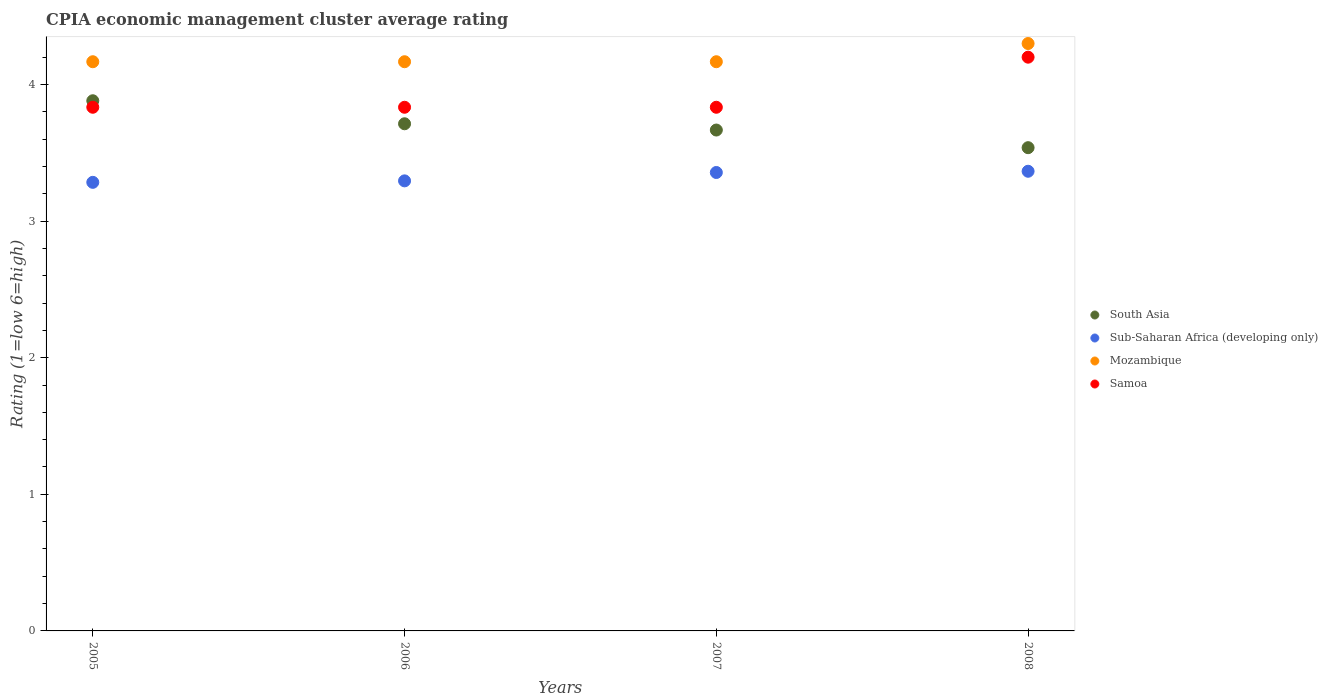How many different coloured dotlines are there?
Make the answer very short. 4. Across all years, what is the maximum CPIA rating in Mozambique?
Provide a short and direct response. 4.3. Across all years, what is the minimum CPIA rating in Sub-Saharan Africa (developing only)?
Provide a short and direct response. 3.28. What is the total CPIA rating in Mozambique in the graph?
Offer a very short reply. 16.8. What is the difference between the CPIA rating in Sub-Saharan Africa (developing only) in 2006 and that in 2007?
Ensure brevity in your answer.  -0.06. What is the difference between the CPIA rating in Sub-Saharan Africa (developing only) in 2005 and the CPIA rating in Mozambique in 2008?
Provide a succinct answer. -1.02. What is the average CPIA rating in Samoa per year?
Ensure brevity in your answer.  3.92. In the year 2006, what is the difference between the CPIA rating in Mozambique and CPIA rating in Sub-Saharan Africa (developing only)?
Your answer should be compact. 0.87. What is the ratio of the CPIA rating in Samoa in 2005 to that in 2008?
Provide a succinct answer. 0.91. What is the difference between the highest and the second highest CPIA rating in Samoa?
Ensure brevity in your answer.  0.37. What is the difference between the highest and the lowest CPIA rating in Sub-Saharan Africa (developing only)?
Offer a terse response. 0.08. Is it the case that in every year, the sum of the CPIA rating in Mozambique and CPIA rating in South Asia  is greater than the sum of CPIA rating in Sub-Saharan Africa (developing only) and CPIA rating in Samoa?
Offer a very short reply. Yes. What is the difference between two consecutive major ticks on the Y-axis?
Give a very brief answer. 1. Does the graph contain grids?
Your answer should be very brief. No. Where does the legend appear in the graph?
Provide a short and direct response. Center right. How many legend labels are there?
Provide a short and direct response. 4. What is the title of the graph?
Provide a succinct answer. CPIA economic management cluster average rating. Does "Tunisia" appear as one of the legend labels in the graph?
Give a very brief answer. No. What is the Rating (1=low 6=high) of South Asia in 2005?
Keep it short and to the point. 3.88. What is the Rating (1=low 6=high) of Sub-Saharan Africa (developing only) in 2005?
Your response must be concise. 3.28. What is the Rating (1=low 6=high) of Mozambique in 2005?
Provide a short and direct response. 4.17. What is the Rating (1=low 6=high) in Samoa in 2005?
Provide a short and direct response. 3.83. What is the Rating (1=low 6=high) in South Asia in 2006?
Your response must be concise. 3.71. What is the Rating (1=low 6=high) of Sub-Saharan Africa (developing only) in 2006?
Keep it short and to the point. 3.29. What is the Rating (1=low 6=high) in Mozambique in 2006?
Ensure brevity in your answer.  4.17. What is the Rating (1=low 6=high) in Samoa in 2006?
Offer a terse response. 3.83. What is the Rating (1=low 6=high) in South Asia in 2007?
Ensure brevity in your answer.  3.67. What is the Rating (1=low 6=high) in Sub-Saharan Africa (developing only) in 2007?
Keep it short and to the point. 3.36. What is the Rating (1=low 6=high) of Mozambique in 2007?
Offer a terse response. 4.17. What is the Rating (1=low 6=high) of Samoa in 2007?
Offer a terse response. 3.83. What is the Rating (1=low 6=high) in South Asia in 2008?
Ensure brevity in your answer.  3.54. What is the Rating (1=low 6=high) in Sub-Saharan Africa (developing only) in 2008?
Your answer should be very brief. 3.36. What is the Rating (1=low 6=high) in Mozambique in 2008?
Offer a very short reply. 4.3. What is the Rating (1=low 6=high) of Samoa in 2008?
Provide a short and direct response. 4.2. Across all years, what is the maximum Rating (1=low 6=high) in South Asia?
Your answer should be very brief. 3.88. Across all years, what is the maximum Rating (1=low 6=high) in Sub-Saharan Africa (developing only)?
Offer a very short reply. 3.36. Across all years, what is the maximum Rating (1=low 6=high) of Samoa?
Make the answer very short. 4.2. Across all years, what is the minimum Rating (1=low 6=high) of South Asia?
Keep it short and to the point. 3.54. Across all years, what is the minimum Rating (1=low 6=high) in Sub-Saharan Africa (developing only)?
Give a very brief answer. 3.28. Across all years, what is the minimum Rating (1=low 6=high) in Mozambique?
Make the answer very short. 4.17. Across all years, what is the minimum Rating (1=low 6=high) in Samoa?
Offer a very short reply. 3.83. What is the total Rating (1=low 6=high) of South Asia in the graph?
Provide a succinct answer. 14.8. What is the total Rating (1=low 6=high) of Sub-Saharan Africa (developing only) in the graph?
Provide a succinct answer. 13.3. What is the total Rating (1=low 6=high) in Samoa in the graph?
Make the answer very short. 15.7. What is the difference between the Rating (1=low 6=high) in South Asia in 2005 and that in 2006?
Offer a very short reply. 0.17. What is the difference between the Rating (1=low 6=high) of Sub-Saharan Africa (developing only) in 2005 and that in 2006?
Provide a short and direct response. -0.01. What is the difference between the Rating (1=low 6=high) of Samoa in 2005 and that in 2006?
Your answer should be very brief. 0. What is the difference between the Rating (1=low 6=high) of South Asia in 2005 and that in 2007?
Your answer should be compact. 0.21. What is the difference between the Rating (1=low 6=high) of Sub-Saharan Africa (developing only) in 2005 and that in 2007?
Offer a very short reply. -0.07. What is the difference between the Rating (1=low 6=high) of Mozambique in 2005 and that in 2007?
Make the answer very short. 0. What is the difference between the Rating (1=low 6=high) of Samoa in 2005 and that in 2007?
Ensure brevity in your answer.  0. What is the difference between the Rating (1=low 6=high) in South Asia in 2005 and that in 2008?
Provide a short and direct response. 0.34. What is the difference between the Rating (1=low 6=high) of Sub-Saharan Africa (developing only) in 2005 and that in 2008?
Provide a succinct answer. -0.08. What is the difference between the Rating (1=low 6=high) of Mozambique in 2005 and that in 2008?
Give a very brief answer. -0.13. What is the difference between the Rating (1=low 6=high) of Samoa in 2005 and that in 2008?
Provide a short and direct response. -0.37. What is the difference between the Rating (1=low 6=high) of South Asia in 2006 and that in 2007?
Your answer should be very brief. 0.05. What is the difference between the Rating (1=low 6=high) in Sub-Saharan Africa (developing only) in 2006 and that in 2007?
Give a very brief answer. -0.06. What is the difference between the Rating (1=low 6=high) of Samoa in 2006 and that in 2007?
Make the answer very short. 0. What is the difference between the Rating (1=low 6=high) in South Asia in 2006 and that in 2008?
Your answer should be compact. 0.17. What is the difference between the Rating (1=low 6=high) of Sub-Saharan Africa (developing only) in 2006 and that in 2008?
Provide a succinct answer. -0.07. What is the difference between the Rating (1=low 6=high) in Mozambique in 2006 and that in 2008?
Your answer should be compact. -0.13. What is the difference between the Rating (1=low 6=high) of Samoa in 2006 and that in 2008?
Give a very brief answer. -0.37. What is the difference between the Rating (1=low 6=high) in South Asia in 2007 and that in 2008?
Keep it short and to the point. 0.13. What is the difference between the Rating (1=low 6=high) in Sub-Saharan Africa (developing only) in 2007 and that in 2008?
Keep it short and to the point. -0.01. What is the difference between the Rating (1=low 6=high) in Mozambique in 2007 and that in 2008?
Provide a short and direct response. -0.13. What is the difference between the Rating (1=low 6=high) of Samoa in 2007 and that in 2008?
Keep it short and to the point. -0.37. What is the difference between the Rating (1=low 6=high) of South Asia in 2005 and the Rating (1=low 6=high) of Sub-Saharan Africa (developing only) in 2006?
Provide a succinct answer. 0.59. What is the difference between the Rating (1=low 6=high) in South Asia in 2005 and the Rating (1=low 6=high) in Mozambique in 2006?
Make the answer very short. -0.29. What is the difference between the Rating (1=low 6=high) in South Asia in 2005 and the Rating (1=low 6=high) in Samoa in 2006?
Your answer should be very brief. 0.05. What is the difference between the Rating (1=low 6=high) in Sub-Saharan Africa (developing only) in 2005 and the Rating (1=low 6=high) in Mozambique in 2006?
Offer a very short reply. -0.88. What is the difference between the Rating (1=low 6=high) of Sub-Saharan Africa (developing only) in 2005 and the Rating (1=low 6=high) of Samoa in 2006?
Offer a very short reply. -0.55. What is the difference between the Rating (1=low 6=high) of Mozambique in 2005 and the Rating (1=low 6=high) of Samoa in 2006?
Your answer should be very brief. 0.33. What is the difference between the Rating (1=low 6=high) of South Asia in 2005 and the Rating (1=low 6=high) of Sub-Saharan Africa (developing only) in 2007?
Offer a terse response. 0.53. What is the difference between the Rating (1=low 6=high) in South Asia in 2005 and the Rating (1=low 6=high) in Mozambique in 2007?
Your answer should be very brief. -0.29. What is the difference between the Rating (1=low 6=high) of South Asia in 2005 and the Rating (1=low 6=high) of Samoa in 2007?
Keep it short and to the point. 0.05. What is the difference between the Rating (1=low 6=high) of Sub-Saharan Africa (developing only) in 2005 and the Rating (1=low 6=high) of Mozambique in 2007?
Offer a terse response. -0.88. What is the difference between the Rating (1=low 6=high) in Sub-Saharan Africa (developing only) in 2005 and the Rating (1=low 6=high) in Samoa in 2007?
Offer a terse response. -0.55. What is the difference between the Rating (1=low 6=high) in South Asia in 2005 and the Rating (1=low 6=high) in Sub-Saharan Africa (developing only) in 2008?
Keep it short and to the point. 0.52. What is the difference between the Rating (1=low 6=high) of South Asia in 2005 and the Rating (1=low 6=high) of Mozambique in 2008?
Your response must be concise. -0.42. What is the difference between the Rating (1=low 6=high) of South Asia in 2005 and the Rating (1=low 6=high) of Samoa in 2008?
Offer a very short reply. -0.32. What is the difference between the Rating (1=low 6=high) in Sub-Saharan Africa (developing only) in 2005 and the Rating (1=low 6=high) in Mozambique in 2008?
Keep it short and to the point. -1.02. What is the difference between the Rating (1=low 6=high) in Sub-Saharan Africa (developing only) in 2005 and the Rating (1=low 6=high) in Samoa in 2008?
Keep it short and to the point. -0.92. What is the difference between the Rating (1=low 6=high) in Mozambique in 2005 and the Rating (1=low 6=high) in Samoa in 2008?
Your answer should be compact. -0.03. What is the difference between the Rating (1=low 6=high) in South Asia in 2006 and the Rating (1=low 6=high) in Sub-Saharan Africa (developing only) in 2007?
Keep it short and to the point. 0.36. What is the difference between the Rating (1=low 6=high) of South Asia in 2006 and the Rating (1=low 6=high) of Mozambique in 2007?
Keep it short and to the point. -0.45. What is the difference between the Rating (1=low 6=high) of South Asia in 2006 and the Rating (1=low 6=high) of Samoa in 2007?
Make the answer very short. -0.12. What is the difference between the Rating (1=low 6=high) in Sub-Saharan Africa (developing only) in 2006 and the Rating (1=low 6=high) in Mozambique in 2007?
Keep it short and to the point. -0.87. What is the difference between the Rating (1=low 6=high) of Sub-Saharan Africa (developing only) in 2006 and the Rating (1=low 6=high) of Samoa in 2007?
Your answer should be compact. -0.54. What is the difference between the Rating (1=low 6=high) in South Asia in 2006 and the Rating (1=low 6=high) in Sub-Saharan Africa (developing only) in 2008?
Offer a terse response. 0.35. What is the difference between the Rating (1=low 6=high) of South Asia in 2006 and the Rating (1=low 6=high) of Mozambique in 2008?
Your answer should be compact. -0.59. What is the difference between the Rating (1=low 6=high) of South Asia in 2006 and the Rating (1=low 6=high) of Samoa in 2008?
Ensure brevity in your answer.  -0.49. What is the difference between the Rating (1=low 6=high) of Sub-Saharan Africa (developing only) in 2006 and the Rating (1=low 6=high) of Mozambique in 2008?
Your response must be concise. -1.01. What is the difference between the Rating (1=low 6=high) of Sub-Saharan Africa (developing only) in 2006 and the Rating (1=low 6=high) of Samoa in 2008?
Provide a short and direct response. -0.91. What is the difference between the Rating (1=low 6=high) of Mozambique in 2006 and the Rating (1=low 6=high) of Samoa in 2008?
Offer a very short reply. -0.03. What is the difference between the Rating (1=low 6=high) in South Asia in 2007 and the Rating (1=low 6=high) in Sub-Saharan Africa (developing only) in 2008?
Provide a short and direct response. 0.3. What is the difference between the Rating (1=low 6=high) of South Asia in 2007 and the Rating (1=low 6=high) of Mozambique in 2008?
Offer a terse response. -0.63. What is the difference between the Rating (1=low 6=high) of South Asia in 2007 and the Rating (1=low 6=high) of Samoa in 2008?
Your answer should be very brief. -0.53. What is the difference between the Rating (1=low 6=high) in Sub-Saharan Africa (developing only) in 2007 and the Rating (1=low 6=high) in Mozambique in 2008?
Provide a short and direct response. -0.94. What is the difference between the Rating (1=low 6=high) in Sub-Saharan Africa (developing only) in 2007 and the Rating (1=low 6=high) in Samoa in 2008?
Give a very brief answer. -0.84. What is the difference between the Rating (1=low 6=high) in Mozambique in 2007 and the Rating (1=low 6=high) in Samoa in 2008?
Provide a succinct answer. -0.03. What is the average Rating (1=low 6=high) of South Asia per year?
Keep it short and to the point. 3.7. What is the average Rating (1=low 6=high) of Sub-Saharan Africa (developing only) per year?
Give a very brief answer. 3.32. What is the average Rating (1=low 6=high) in Mozambique per year?
Provide a succinct answer. 4.2. What is the average Rating (1=low 6=high) of Samoa per year?
Your answer should be compact. 3.92. In the year 2005, what is the difference between the Rating (1=low 6=high) of South Asia and Rating (1=low 6=high) of Sub-Saharan Africa (developing only)?
Offer a terse response. 0.6. In the year 2005, what is the difference between the Rating (1=low 6=high) in South Asia and Rating (1=low 6=high) in Mozambique?
Offer a terse response. -0.29. In the year 2005, what is the difference between the Rating (1=low 6=high) in South Asia and Rating (1=low 6=high) in Samoa?
Provide a succinct answer. 0.05. In the year 2005, what is the difference between the Rating (1=low 6=high) in Sub-Saharan Africa (developing only) and Rating (1=low 6=high) in Mozambique?
Give a very brief answer. -0.88. In the year 2005, what is the difference between the Rating (1=low 6=high) of Sub-Saharan Africa (developing only) and Rating (1=low 6=high) of Samoa?
Ensure brevity in your answer.  -0.55. In the year 2006, what is the difference between the Rating (1=low 6=high) in South Asia and Rating (1=low 6=high) in Sub-Saharan Africa (developing only)?
Give a very brief answer. 0.42. In the year 2006, what is the difference between the Rating (1=low 6=high) of South Asia and Rating (1=low 6=high) of Mozambique?
Give a very brief answer. -0.45. In the year 2006, what is the difference between the Rating (1=low 6=high) in South Asia and Rating (1=low 6=high) in Samoa?
Provide a short and direct response. -0.12. In the year 2006, what is the difference between the Rating (1=low 6=high) in Sub-Saharan Africa (developing only) and Rating (1=low 6=high) in Mozambique?
Offer a terse response. -0.87. In the year 2006, what is the difference between the Rating (1=low 6=high) of Sub-Saharan Africa (developing only) and Rating (1=low 6=high) of Samoa?
Provide a succinct answer. -0.54. In the year 2006, what is the difference between the Rating (1=low 6=high) of Mozambique and Rating (1=low 6=high) of Samoa?
Your answer should be compact. 0.33. In the year 2007, what is the difference between the Rating (1=low 6=high) of South Asia and Rating (1=low 6=high) of Sub-Saharan Africa (developing only)?
Make the answer very short. 0.31. In the year 2007, what is the difference between the Rating (1=low 6=high) in South Asia and Rating (1=low 6=high) in Mozambique?
Your answer should be very brief. -0.5. In the year 2007, what is the difference between the Rating (1=low 6=high) in Sub-Saharan Africa (developing only) and Rating (1=low 6=high) in Mozambique?
Make the answer very short. -0.81. In the year 2007, what is the difference between the Rating (1=low 6=high) of Sub-Saharan Africa (developing only) and Rating (1=low 6=high) of Samoa?
Your answer should be compact. -0.48. In the year 2008, what is the difference between the Rating (1=low 6=high) of South Asia and Rating (1=low 6=high) of Sub-Saharan Africa (developing only)?
Provide a short and direct response. 0.17. In the year 2008, what is the difference between the Rating (1=low 6=high) of South Asia and Rating (1=low 6=high) of Mozambique?
Give a very brief answer. -0.76. In the year 2008, what is the difference between the Rating (1=low 6=high) in South Asia and Rating (1=low 6=high) in Samoa?
Provide a short and direct response. -0.66. In the year 2008, what is the difference between the Rating (1=low 6=high) of Sub-Saharan Africa (developing only) and Rating (1=low 6=high) of Mozambique?
Give a very brief answer. -0.94. In the year 2008, what is the difference between the Rating (1=low 6=high) in Sub-Saharan Africa (developing only) and Rating (1=low 6=high) in Samoa?
Make the answer very short. -0.84. In the year 2008, what is the difference between the Rating (1=low 6=high) in Mozambique and Rating (1=low 6=high) in Samoa?
Offer a very short reply. 0.1. What is the ratio of the Rating (1=low 6=high) of South Asia in 2005 to that in 2006?
Your response must be concise. 1.05. What is the ratio of the Rating (1=low 6=high) in Mozambique in 2005 to that in 2006?
Ensure brevity in your answer.  1. What is the ratio of the Rating (1=low 6=high) of Samoa in 2005 to that in 2006?
Your response must be concise. 1. What is the ratio of the Rating (1=low 6=high) in South Asia in 2005 to that in 2007?
Offer a very short reply. 1.06. What is the ratio of the Rating (1=low 6=high) in Sub-Saharan Africa (developing only) in 2005 to that in 2007?
Give a very brief answer. 0.98. What is the ratio of the Rating (1=low 6=high) in South Asia in 2005 to that in 2008?
Offer a terse response. 1.1. What is the ratio of the Rating (1=low 6=high) in Sub-Saharan Africa (developing only) in 2005 to that in 2008?
Ensure brevity in your answer.  0.98. What is the ratio of the Rating (1=low 6=high) in Mozambique in 2005 to that in 2008?
Your response must be concise. 0.97. What is the ratio of the Rating (1=low 6=high) of Samoa in 2005 to that in 2008?
Give a very brief answer. 0.91. What is the ratio of the Rating (1=low 6=high) of South Asia in 2006 to that in 2007?
Offer a terse response. 1.01. What is the ratio of the Rating (1=low 6=high) in Sub-Saharan Africa (developing only) in 2006 to that in 2007?
Your response must be concise. 0.98. What is the ratio of the Rating (1=low 6=high) in South Asia in 2006 to that in 2008?
Ensure brevity in your answer.  1.05. What is the ratio of the Rating (1=low 6=high) of Sub-Saharan Africa (developing only) in 2006 to that in 2008?
Offer a very short reply. 0.98. What is the ratio of the Rating (1=low 6=high) in Mozambique in 2006 to that in 2008?
Provide a short and direct response. 0.97. What is the ratio of the Rating (1=low 6=high) in Samoa in 2006 to that in 2008?
Provide a succinct answer. 0.91. What is the ratio of the Rating (1=low 6=high) in South Asia in 2007 to that in 2008?
Your answer should be compact. 1.04. What is the ratio of the Rating (1=low 6=high) in Samoa in 2007 to that in 2008?
Provide a succinct answer. 0.91. What is the difference between the highest and the second highest Rating (1=low 6=high) of South Asia?
Your response must be concise. 0.17. What is the difference between the highest and the second highest Rating (1=low 6=high) of Sub-Saharan Africa (developing only)?
Offer a very short reply. 0.01. What is the difference between the highest and the second highest Rating (1=low 6=high) of Mozambique?
Provide a succinct answer. 0.13. What is the difference between the highest and the second highest Rating (1=low 6=high) of Samoa?
Your response must be concise. 0.37. What is the difference between the highest and the lowest Rating (1=low 6=high) of South Asia?
Ensure brevity in your answer.  0.34. What is the difference between the highest and the lowest Rating (1=low 6=high) of Sub-Saharan Africa (developing only)?
Your answer should be compact. 0.08. What is the difference between the highest and the lowest Rating (1=low 6=high) in Mozambique?
Provide a short and direct response. 0.13. What is the difference between the highest and the lowest Rating (1=low 6=high) in Samoa?
Offer a terse response. 0.37. 